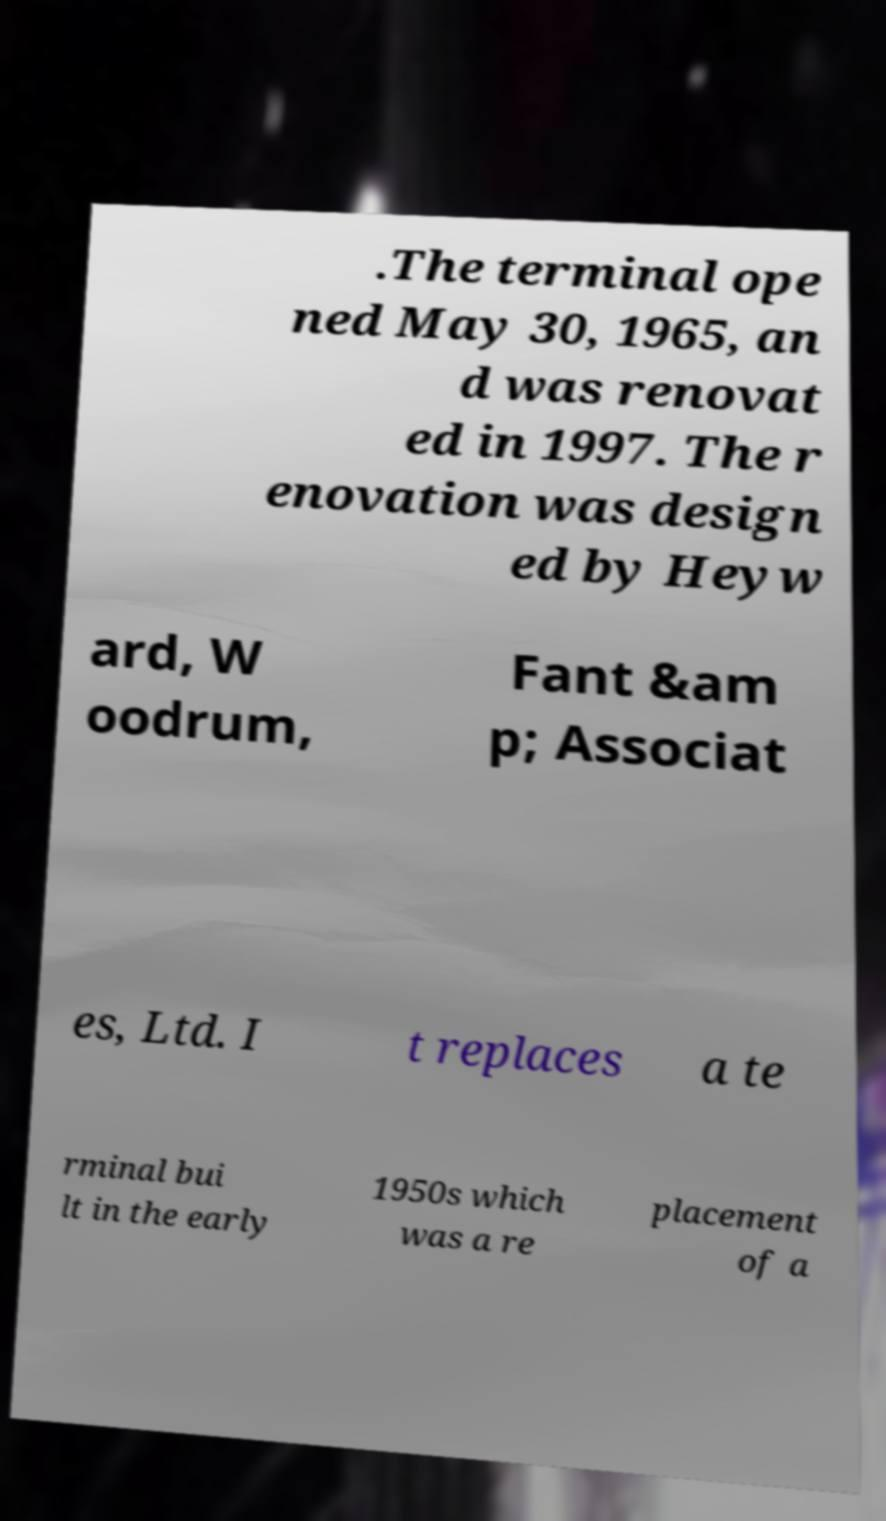Please identify and transcribe the text found in this image. .The terminal ope ned May 30, 1965, an d was renovat ed in 1997. The r enovation was design ed by Heyw ard, W oodrum, Fant &am p; Associat es, Ltd. I t replaces a te rminal bui lt in the early 1950s which was a re placement of a 